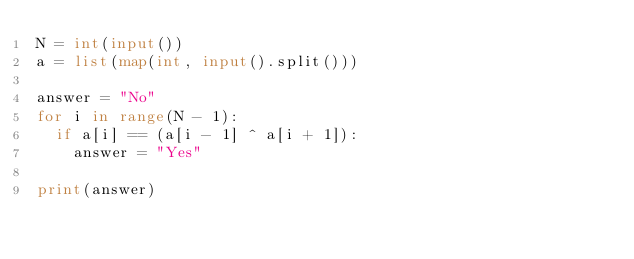<code> <loc_0><loc_0><loc_500><loc_500><_Python_>N = int(input())
a = list(map(int, input().split()))

answer = "No"
for i in range(N - 1):
  if a[i] == (a[i - 1] ^ a[i + 1]):
    answer = "Yes"
    
print(answer)
</code> 